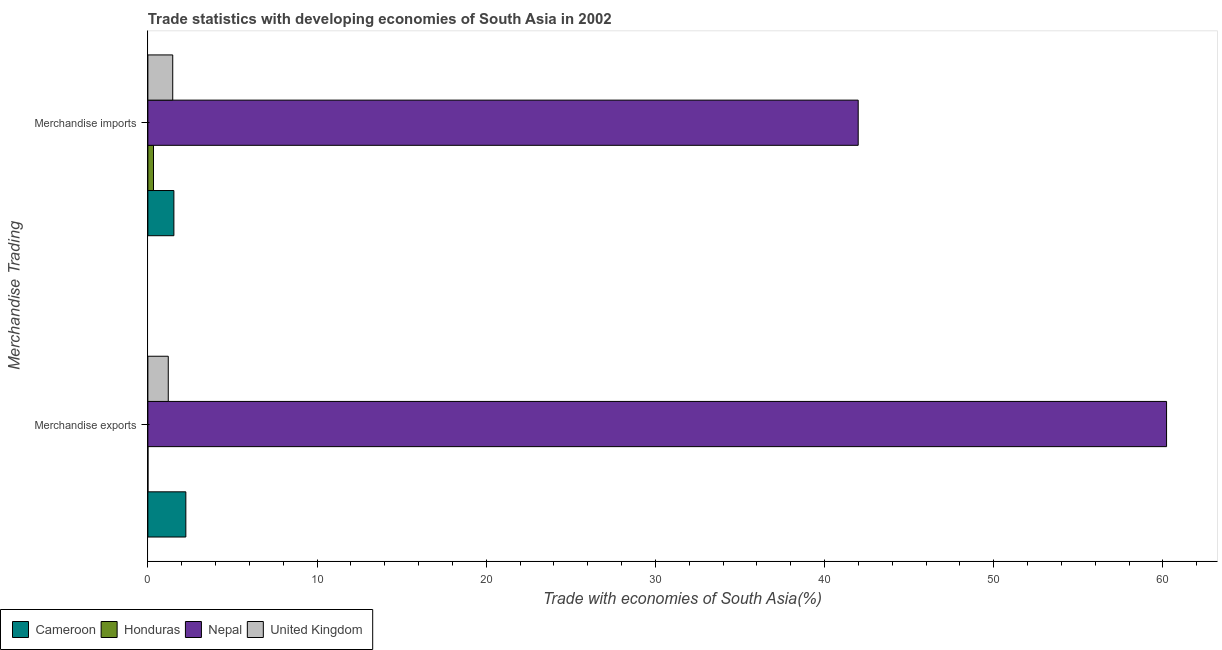How many groups of bars are there?
Keep it short and to the point. 2. Are the number of bars on each tick of the Y-axis equal?
Make the answer very short. Yes. How many bars are there on the 2nd tick from the bottom?
Offer a terse response. 4. What is the merchandise imports in United Kingdom?
Keep it short and to the point. 1.47. Across all countries, what is the maximum merchandise exports?
Offer a terse response. 60.22. Across all countries, what is the minimum merchandise imports?
Make the answer very short. 0.33. In which country was the merchandise exports maximum?
Your answer should be very brief. Nepal. In which country was the merchandise exports minimum?
Provide a succinct answer. Honduras. What is the total merchandise exports in the graph?
Provide a succinct answer. 63.67. What is the difference between the merchandise imports in Nepal and that in United Kingdom?
Provide a short and direct response. 40.52. What is the difference between the merchandise exports in Cameroon and the merchandise imports in United Kingdom?
Keep it short and to the point. 0.78. What is the average merchandise imports per country?
Offer a very short reply. 11.33. What is the difference between the merchandise imports and merchandise exports in Honduras?
Make the answer very short. 0.33. What is the ratio of the merchandise exports in Nepal to that in Honduras?
Make the answer very short. 1.27e+04. Is the merchandise imports in Cameroon less than that in Nepal?
Offer a very short reply. Yes. What does the 3rd bar from the top in Merchandise imports represents?
Ensure brevity in your answer.  Honduras. What does the 1st bar from the bottom in Merchandise imports represents?
Provide a short and direct response. Cameroon. How many countries are there in the graph?
Keep it short and to the point. 4. Does the graph contain any zero values?
Your answer should be very brief. No. Does the graph contain grids?
Make the answer very short. No. Where does the legend appear in the graph?
Provide a succinct answer. Bottom left. How are the legend labels stacked?
Your response must be concise. Horizontal. What is the title of the graph?
Make the answer very short. Trade statistics with developing economies of South Asia in 2002. Does "St. Kitts and Nevis" appear as one of the legend labels in the graph?
Provide a succinct answer. No. What is the label or title of the X-axis?
Give a very brief answer. Trade with economies of South Asia(%). What is the label or title of the Y-axis?
Offer a very short reply. Merchandise Trading. What is the Trade with economies of South Asia(%) of Cameroon in Merchandise exports?
Your answer should be very brief. 2.24. What is the Trade with economies of South Asia(%) of Honduras in Merchandise exports?
Offer a terse response. 0. What is the Trade with economies of South Asia(%) of Nepal in Merchandise exports?
Keep it short and to the point. 60.22. What is the Trade with economies of South Asia(%) of United Kingdom in Merchandise exports?
Your answer should be compact. 1.21. What is the Trade with economies of South Asia(%) of Cameroon in Merchandise imports?
Keep it short and to the point. 1.54. What is the Trade with economies of South Asia(%) of Honduras in Merchandise imports?
Your answer should be compact. 0.33. What is the Trade with economies of South Asia(%) of Nepal in Merchandise imports?
Keep it short and to the point. 41.99. What is the Trade with economies of South Asia(%) of United Kingdom in Merchandise imports?
Ensure brevity in your answer.  1.47. Across all Merchandise Trading, what is the maximum Trade with economies of South Asia(%) in Cameroon?
Keep it short and to the point. 2.24. Across all Merchandise Trading, what is the maximum Trade with economies of South Asia(%) in Honduras?
Ensure brevity in your answer.  0.33. Across all Merchandise Trading, what is the maximum Trade with economies of South Asia(%) in Nepal?
Make the answer very short. 60.22. Across all Merchandise Trading, what is the maximum Trade with economies of South Asia(%) in United Kingdom?
Provide a short and direct response. 1.47. Across all Merchandise Trading, what is the minimum Trade with economies of South Asia(%) in Cameroon?
Provide a succinct answer. 1.54. Across all Merchandise Trading, what is the minimum Trade with economies of South Asia(%) in Honduras?
Offer a very short reply. 0. Across all Merchandise Trading, what is the minimum Trade with economies of South Asia(%) of Nepal?
Give a very brief answer. 41.99. Across all Merchandise Trading, what is the minimum Trade with economies of South Asia(%) in United Kingdom?
Your answer should be very brief. 1.21. What is the total Trade with economies of South Asia(%) of Cameroon in the graph?
Offer a very short reply. 3.78. What is the total Trade with economies of South Asia(%) in Honduras in the graph?
Your answer should be compact. 0.34. What is the total Trade with economies of South Asia(%) of Nepal in the graph?
Your answer should be very brief. 102.21. What is the total Trade with economies of South Asia(%) of United Kingdom in the graph?
Offer a terse response. 2.67. What is the difference between the Trade with economies of South Asia(%) of Cameroon in Merchandise exports and that in Merchandise imports?
Your response must be concise. 0.71. What is the difference between the Trade with economies of South Asia(%) of Honduras in Merchandise exports and that in Merchandise imports?
Offer a very short reply. -0.33. What is the difference between the Trade with economies of South Asia(%) in Nepal in Merchandise exports and that in Merchandise imports?
Provide a succinct answer. 18.23. What is the difference between the Trade with economies of South Asia(%) in United Kingdom in Merchandise exports and that in Merchandise imports?
Ensure brevity in your answer.  -0.26. What is the difference between the Trade with economies of South Asia(%) of Cameroon in Merchandise exports and the Trade with economies of South Asia(%) of Honduras in Merchandise imports?
Your answer should be very brief. 1.91. What is the difference between the Trade with economies of South Asia(%) in Cameroon in Merchandise exports and the Trade with economies of South Asia(%) in Nepal in Merchandise imports?
Give a very brief answer. -39.74. What is the difference between the Trade with economies of South Asia(%) in Cameroon in Merchandise exports and the Trade with economies of South Asia(%) in United Kingdom in Merchandise imports?
Your answer should be compact. 0.78. What is the difference between the Trade with economies of South Asia(%) of Honduras in Merchandise exports and the Trade with economies of South Asia(%) of Nepal in Merchandise imports?
Provide a short and direct response. -41.98. What is the difference between the Trade with economies of South Asia(%) of Honduras in Merchandise exports and the Trade with economies of South Asia(%) of United Kingdom in Merchandise imports?
Give a very brief answer. -1.46. What is the difference between the Trade with economies of South Asia(%) in Nepal in Merchandise exports and the Trade with economies of South Asia(%) in United Kingdom in Merchandise imports?
Offer a terse response. 58.75. What is the average Trade with economies of South Asia(%) in Cameroon per Merchandise Trading?
Give a very brief answer. 1.89. What is the average Trade with economies of South Asia(%) in Honduras per Merchandise Trading?
Ensure brevity in your answer.  0.17. What is the average Trade with economies of South Asia(%) in Nepal per Merchandise Trading?
Give a very brief answer. 51.1. What is the average Trade with economies of South Asia(%) of United Kingdom per Merchandise Trading?
Make the answer very short. 1.34. What is the difference between the Trade with economies of South Asia(%) in Cameroon and Trade with economies of South Asia(%) in Honduras in Merchandise exports?
Give a very brief answer. 2.24. What is the difference between the Trade with economies of South Asia(%) of Cameroon and Trade with economies of South Asia(%) of Nepal in Merchandise exports?
Ensure brevity in your answer.  -57.97. What is the difference between the Trade with economies of South Asia(%) in Cameroon and Trade with economies of South Asia(%) in United Kingdom in Merchandise exports?
Your answer should be very brief. 1.04. What is the difference between the Trade with economies of South Asia(%) of Honduras and Trade with economies of South Asia(%) of Nepal in Merchandise exports?
Your response must be concise. -60.21. What is the difference between the Trade with economies of South Asia(%) in Honduras and Trade with economies of South Asia(%) in United Kingdom in Merchandise exports?
Keep it short and to the point. -1.2. What is the difference between the Trade with economies of South Asia(%) in Nepal and Trade with economies of South Asia(%) in United Kingdom in Merchandise exports?
Your response must be concise. 59.01. What is the difference between the Trade with economies of South Asia(%) of Cameroon and Trade with economies of South Asia(%) of Honduras in Merchandise imports?
Your answer should be compact. 1.21. What is the difference between the Trade with economies of South Asia(%) in Cameroon and Trade with economies of South Asia(%) in Nepal in Merchandise imports?
Offer a terse response. -40.45. What is the difference between the Trade with economies of South Asia(%) in Cameroon and Trade with economies of South Asia(%) in United Kingdom in Merchandise imports?
Your response must be concise. 0.07. What is the difference between the Trade with economies of South Asia(%) in Honduras and Trade with economies of South Asia(%) in Nepal in Merchandise imports?
Provide a succinct answer. -41.66. What is the difference between the Trade with economies of South Asia(%) in Honduras and Trade with economies of South Asia(%) in United Kingdom in Merchandise imports?
Offer a terse response. -1.14. What is the difference between the Trade with economies of South Asia(%) of Nepal and Trade with economies of South Asia(%) of United Kingdom in Merchandise imports?
Give a very brief answer. 40.52. What is the ratio of the Trade with economies of South Asia(%) of Cameroon in Merchandise exports to that in Merchandise imports?
Make the answer very short. 1.46. What is the ratio of the Trade with economies of South Asia(%) in Honduras in Merchandise exports to that in Merchandise imports?
Ensure brevity in your answer.  0.01. What is the ratio of the Trade with economies of South Asia(%) in Nepal in Merchandise exports to that in Merchandise imports?
Ensure brevity in your answer.  1.43. What is the ratio of the Trade with economies of South Asia(%) in United Kingdom in Merchandise exports to that in Merchandise imports?
Your answer should be very brief. 0.82. What is the difference between the highest and the second highest Trade with economies of South Asia(%) in Cameroon?
Give a very brief answer. 0.71. What is the difference between the highest and the second highest Trade with economies of South Asia(%) of Honduras?
Provide a short and direct response. 0.33. What is the difference between the highest and the second highest Trade with economies of South Asia(%) of Nepal?
Ensure brevity in your answer.  18.23. What is the difference between the highest and the second highest Trade with economies of South Asia(%) in United Kingdom?
Your answer should be very brief. 0.26. What is the difference between the highest and the lowest Trade with economies of South Asia(%) in Cameroon?
Offer a terse response. 0.71. What is the difference between the highest and the lowest Trade with economies of South Asia(%) in Honduras?
Ensure brevity in your answer.  0.33. What is the difference between the highest and the lowest Trade with economies of South Asia(%) in Nepal?
Make the answer very short. 18.23. What is the difference between the highest and the lowest Trade with economies of South Asia(%) in United Kingdom?
Ensure brevity in your answer.  0.26. 